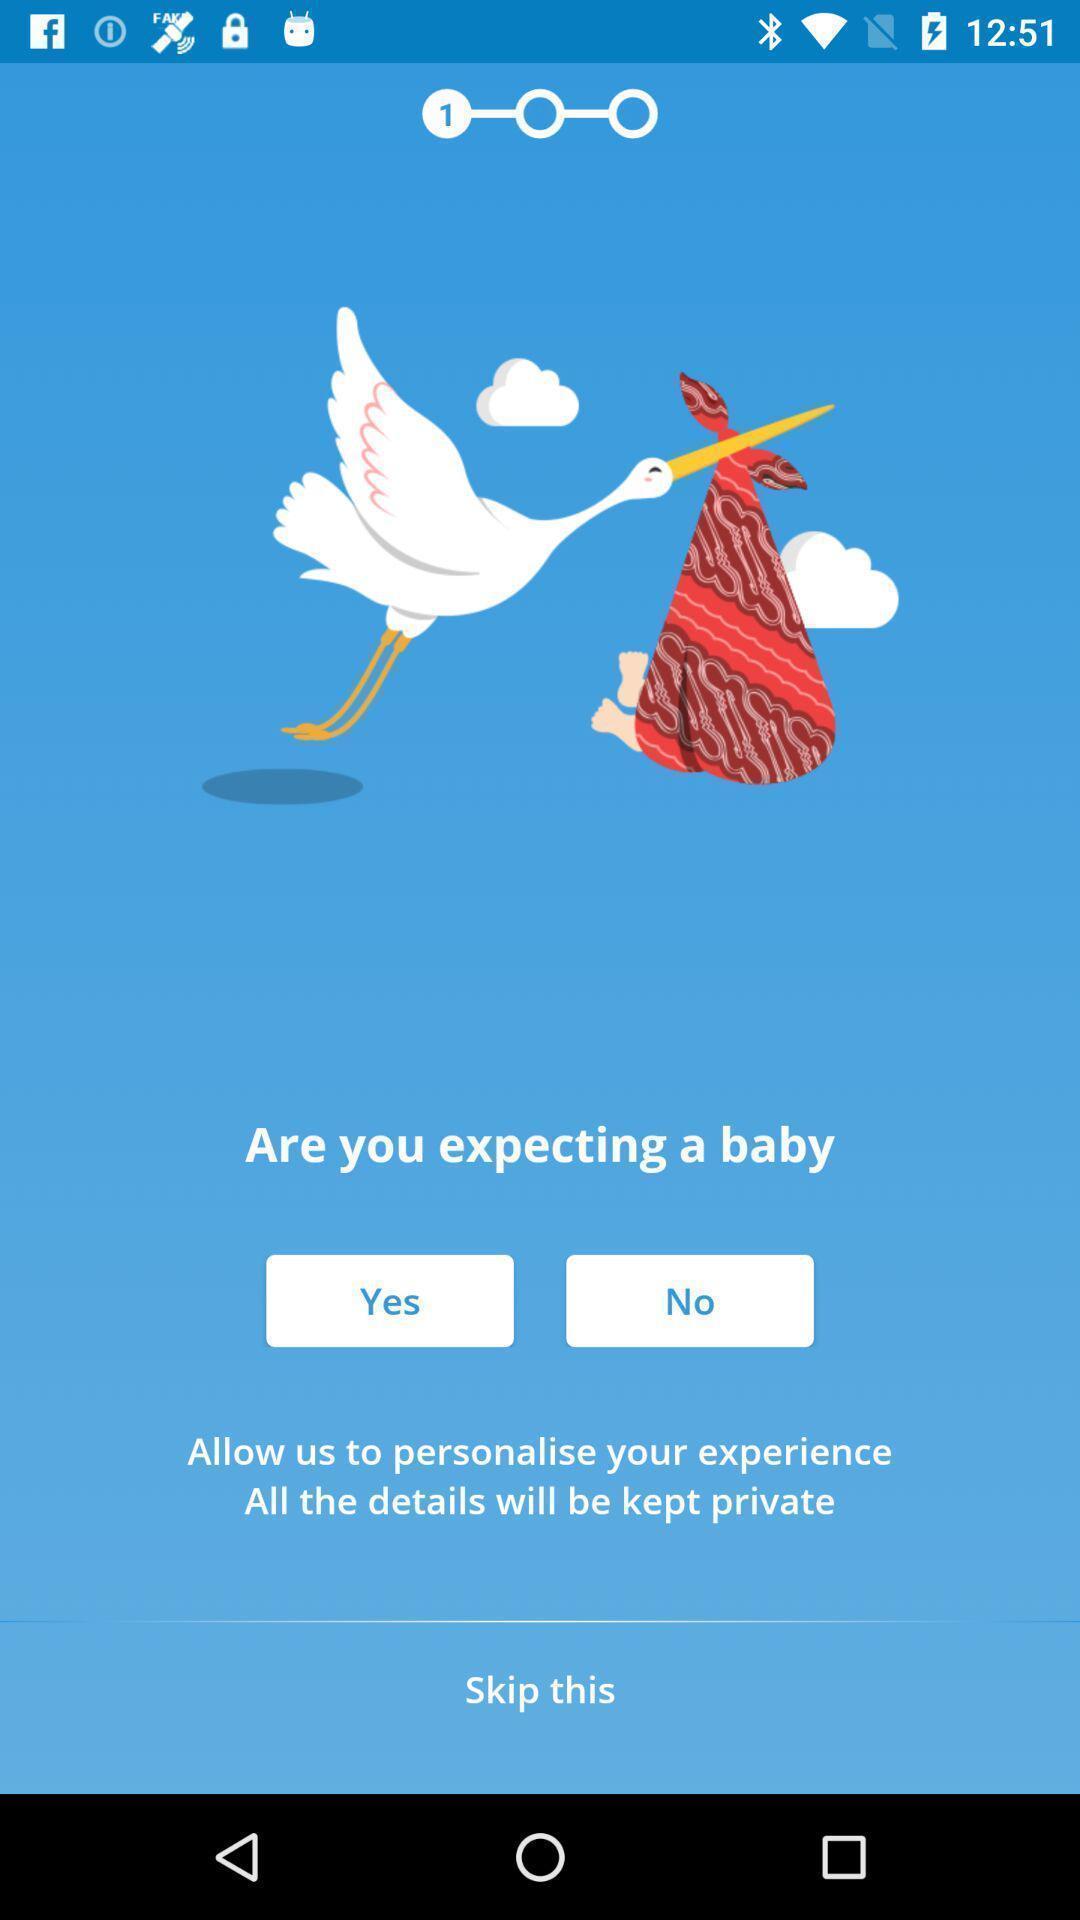Describe the key features of this screenshot. Welcome page. 